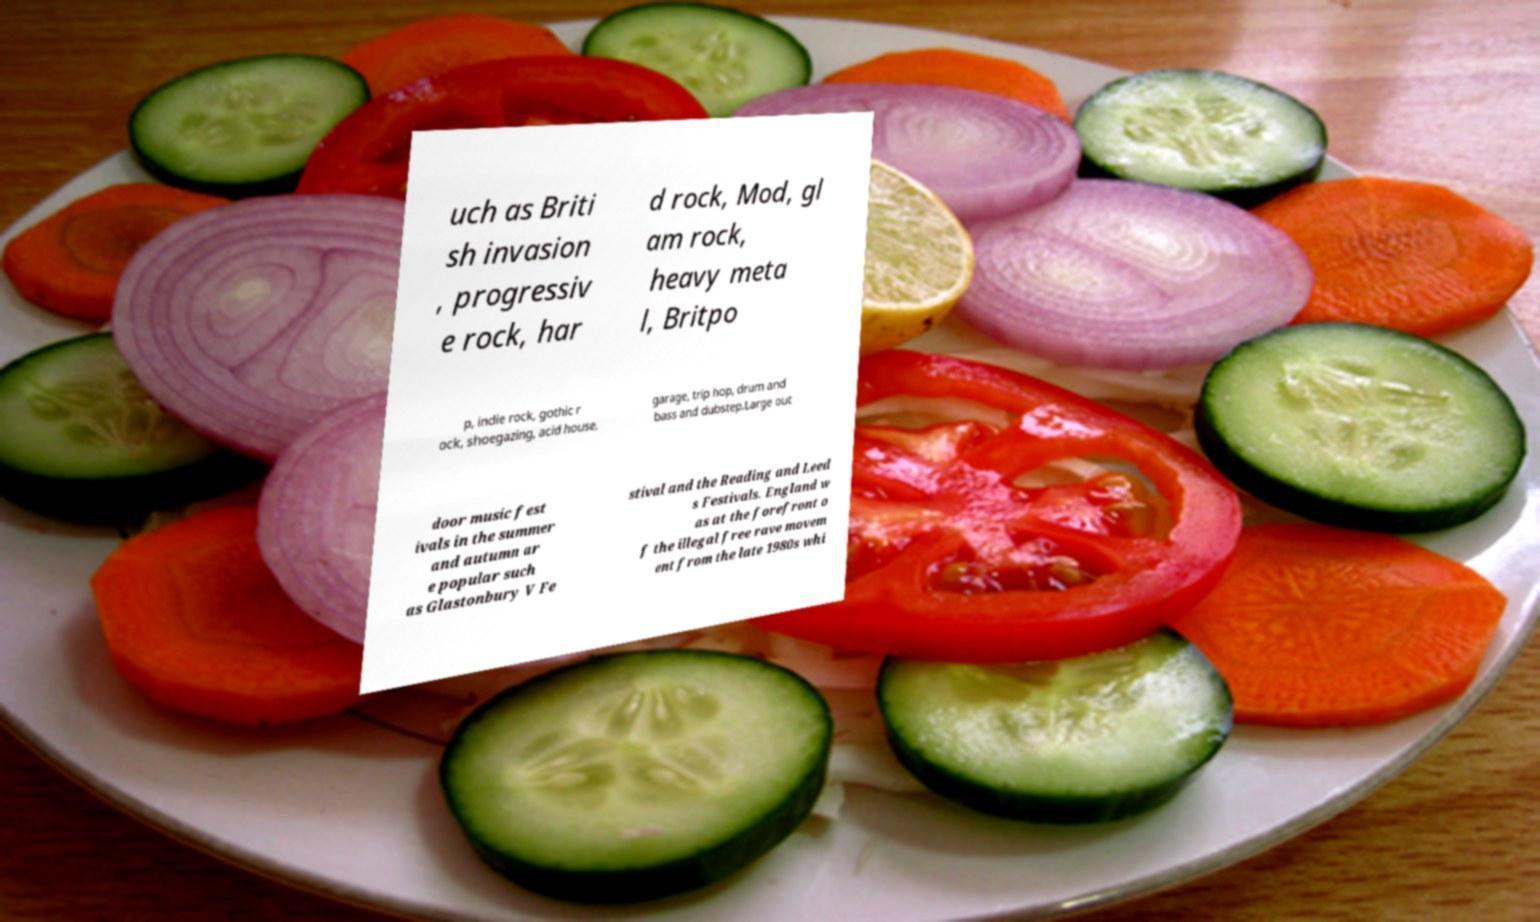Can you accurately transcribe the text from the provided image for me? uch as Briti sh invasion , progressiv e rock, har d rock, Mod, gl am rock, heavy meta l, Britpo p, indie rock, gothic r ock, shoegazing, acid house, garage, trip hop, drum and bass and dubstep.Large out door music fest ivals in the summer and autumn ar e popular such as Glastonbury V Fe stival and the Reading and Leed s Festivals. England w as at the forefront o f the illegal free rave movem ent from the late 1980s whi 